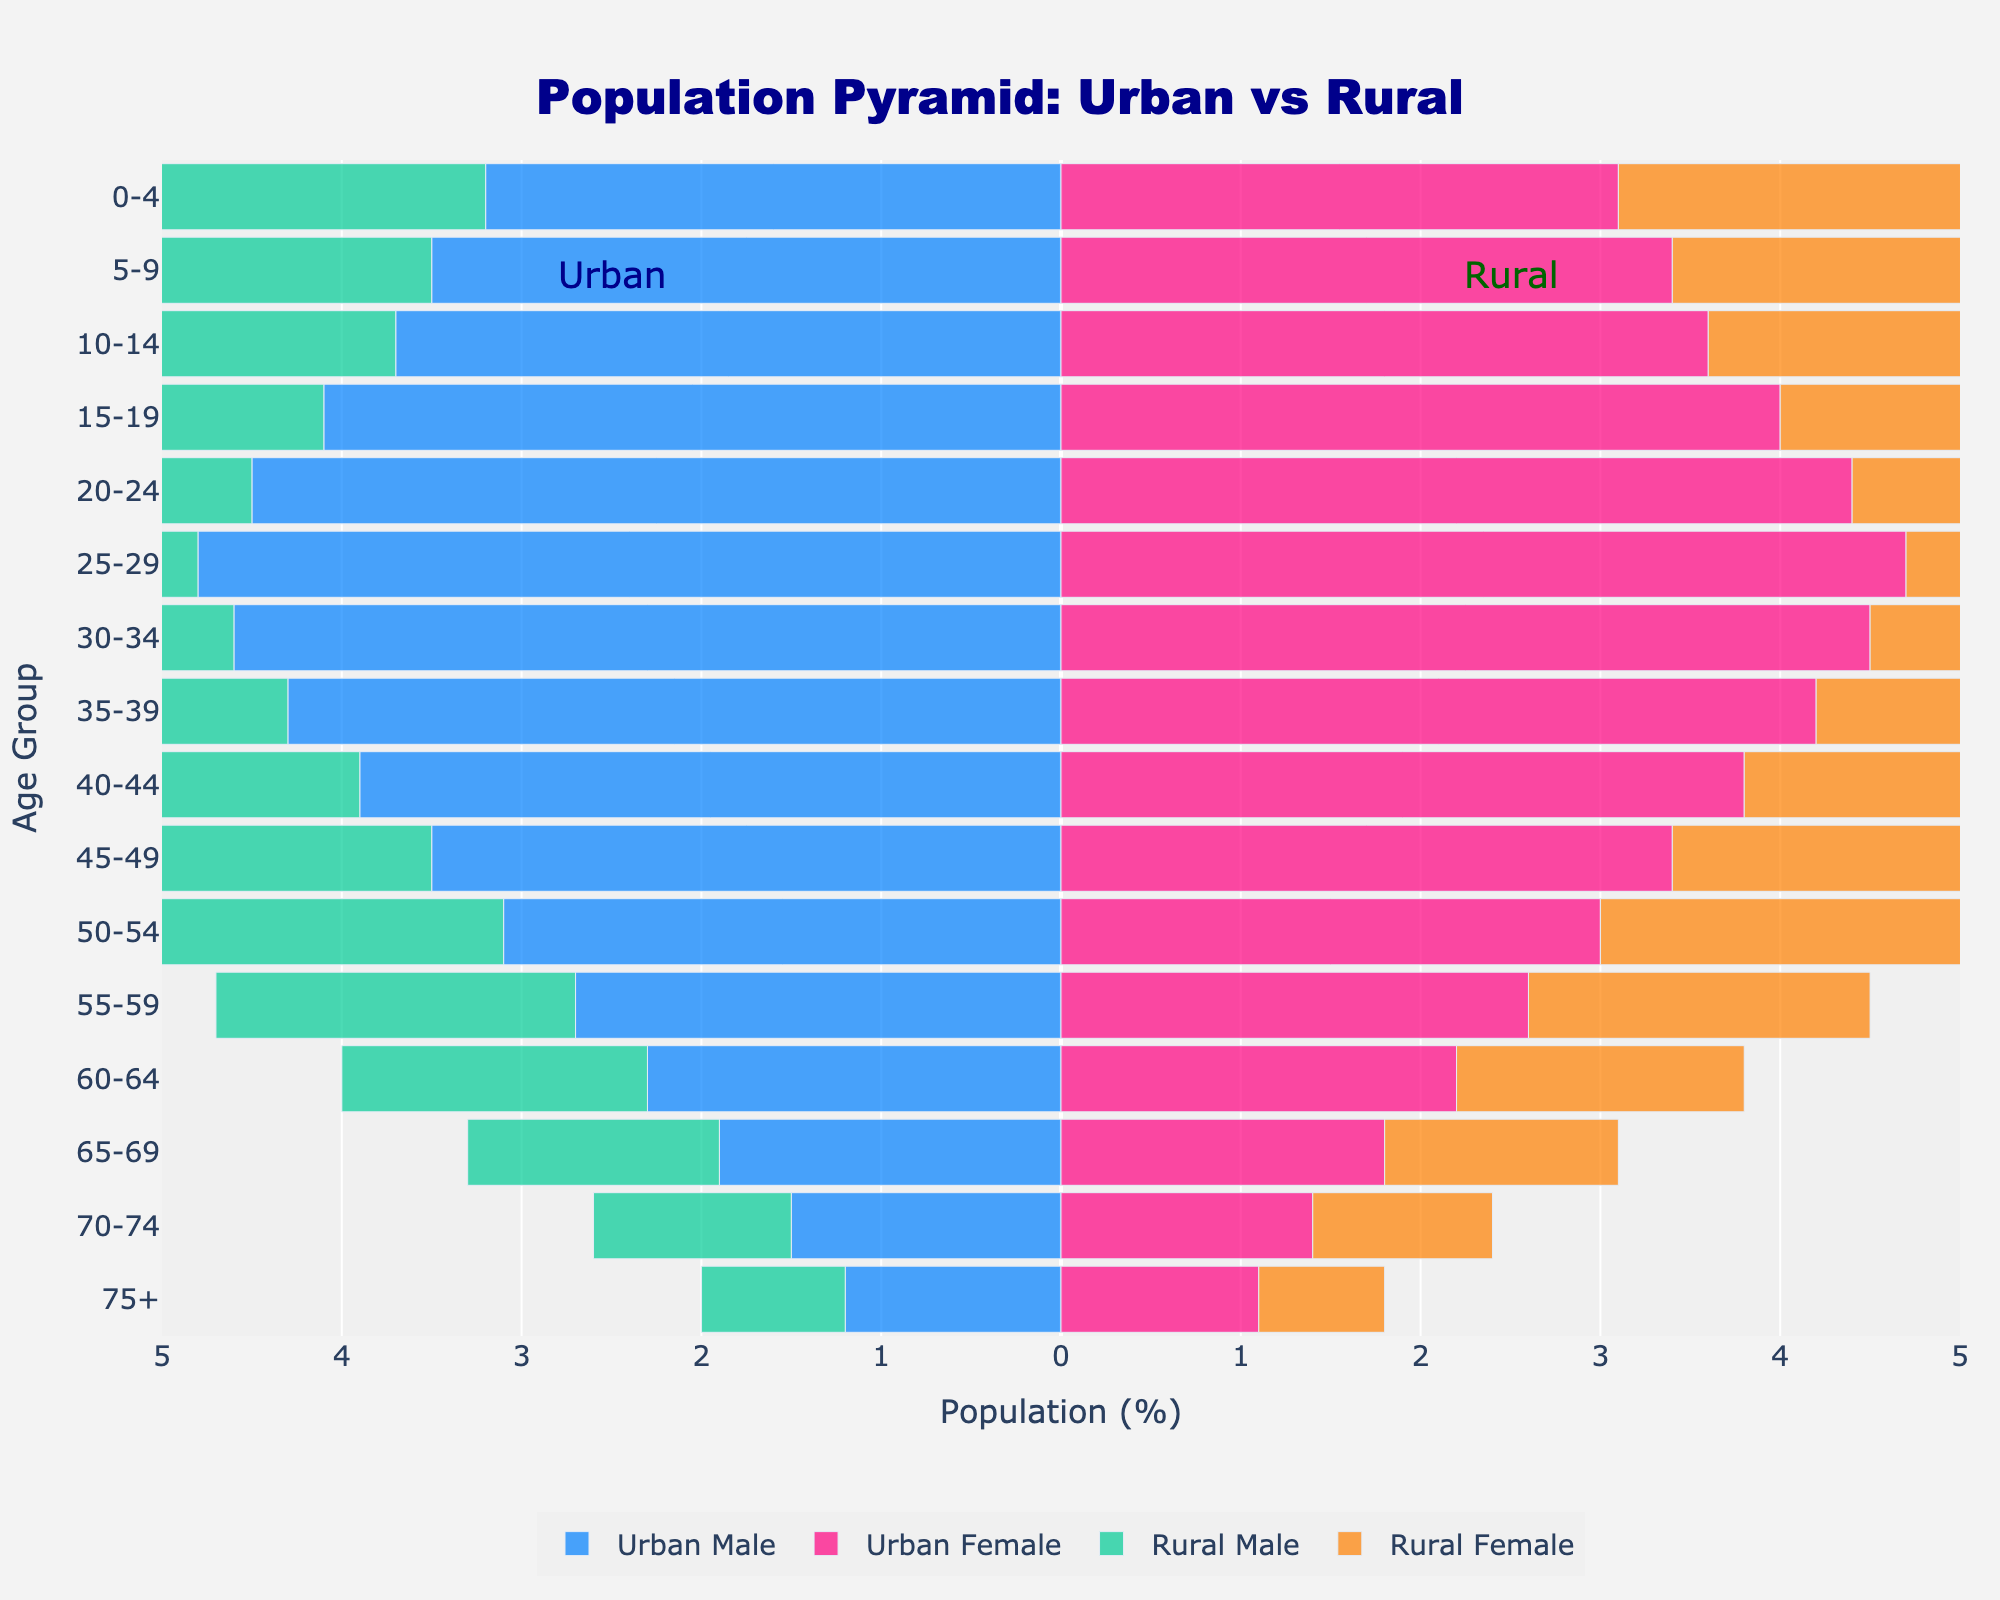What is the title of the figure? The title of the figure is clearly placed at the top center of the plot.
Answer: Population Pyramid: Urban vs Rural What age group has the highest percentage for rural males? By looking at the bars representing rural males (green bars on the left), the age group 10-14 has the longest bar, indicating the highest percentage.
Answer: 10-14 Which age group has a higher urban male percentage compared to rural male percentage? Observe the blue bars for urban males on the left and compare them to the green bars for rural males on the same side. The 25-29 age group has longer blue bars than green bars.
Answer: 25-29 Which group has the smallest percentage for ages 75+? Look at the bars representing ages 75+ for all four groups. The shortest bar belongs to rural females.
Answer: Rural Female How does the percentage of urban females change from the age group 0-4 to 10-14? Compare the pink bars for urban females from age group 0-4 to 10-14. The 0-4 age group has a percentage of 3.1, 3.4 for 5-9, and 3.6 for 10-14. Overall, the percentage increases from 0-4 to 10-14.
Answer: Increases What is the difference in percentage between urban males and females in the 30-34 age group? The percentage for urban males in 30-34 is 4.6, and for urban females, it is 4.5. Subtract the female percentage from the male percentage. 4.6 - 4.5 = 0.1.
Answer: 0.1 In the age group 20-24, which group has the higher percentage, rural males or urban males? For the age group 20-24, compare the length of the blue bar (urban males) and the green bar (rural males) on the left side. Urban males (4.5) have a longer bar than rural males (4.2).
Answer: Urban males What happens to the percentage of rural females from ages 55-59 to 75+? Observe the orange bars for rural females from ages 55-59 to 75+. The percentages are 1.9, 1.6, 1.3, 1.0, and 0.7, showing a continuous decrease.
Answer: Decreases Which age group has the closest percentage between urban and rural populations for both males and females? Compare the bars for both males and females across different age groups. The 10-14 age group has 3.7 (urban male) vs. 4.9 (rural male) and 3.6 (urban female) vs. 4.7 (rural female), showing a relatively close match. 15-19 also shows a close match: 4.1 (urban male) vs. 4.7 (rural male) and 4.0 (urban female) vs. 4.5 (rural female). Both are close, but 15-19 is slightly closer overall.
Answer: 15-19 